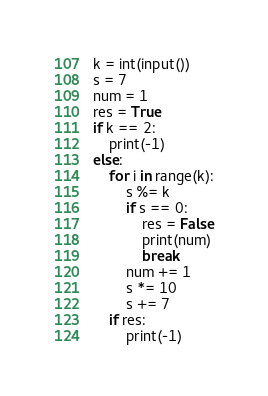<code> <loc_0><loc_0><loc_500><loc_500><_Python_>k = int(input())
s = 7
num = 1
res = True
if k == 2:
    print(-1)
else:
    for i in range(k):
        s %= k
        if s == 0:
            res = False
            print(num)
            break
        num += 1
        s *= 10
        s += 7
    if res:
        print(-1)</code> 